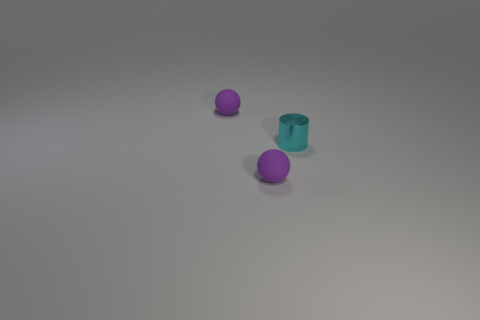What could be the purpose of these objects in the image? The objects don't convey any explicit functionality; they seem to be more like generic models possibly used for display or educational purposes to demonstrate shapes and lighting in a 3D rendering or an art piece. 